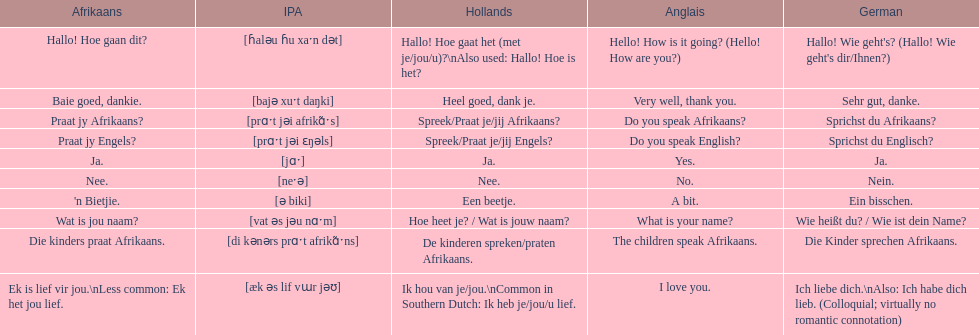What are all of the afrikaans phrases in the list? Hallo! Hoe gaan dit?, Baie goed, dankie., Praat jy Afrikaans?, Praat jy Engels?, Ja., Nee., 'n Bietjie., Wat is jou naam?, Die kinders praat Afrikaans., Ek is lief vir jou.\nLess common: Ek het jou lief. What is the english translation of each phrase? Hello! How is it going? (Hello! How are you?), Very well, thank you., Do you speak Afrikaans?, Do you speak English?, Yes., No., A bit., What is your name?, The children speak Afrikaans., I love you. And which afrikaans phrase translated to do you speak afrikaans? Praat jy Afrikaans?. 